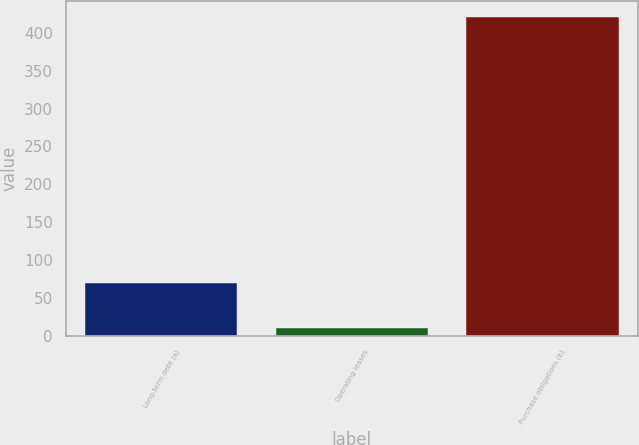Convert chart to OTSL. <chart><loc_0><loc_0><loc_500><loc_500><bar_chart><fcel>Long-term debt (a)<fcel>Operating leases<fcel>Purchase obligations (b)<nl><fcel>70<fcel>10<fcel>421<nl></chart> 